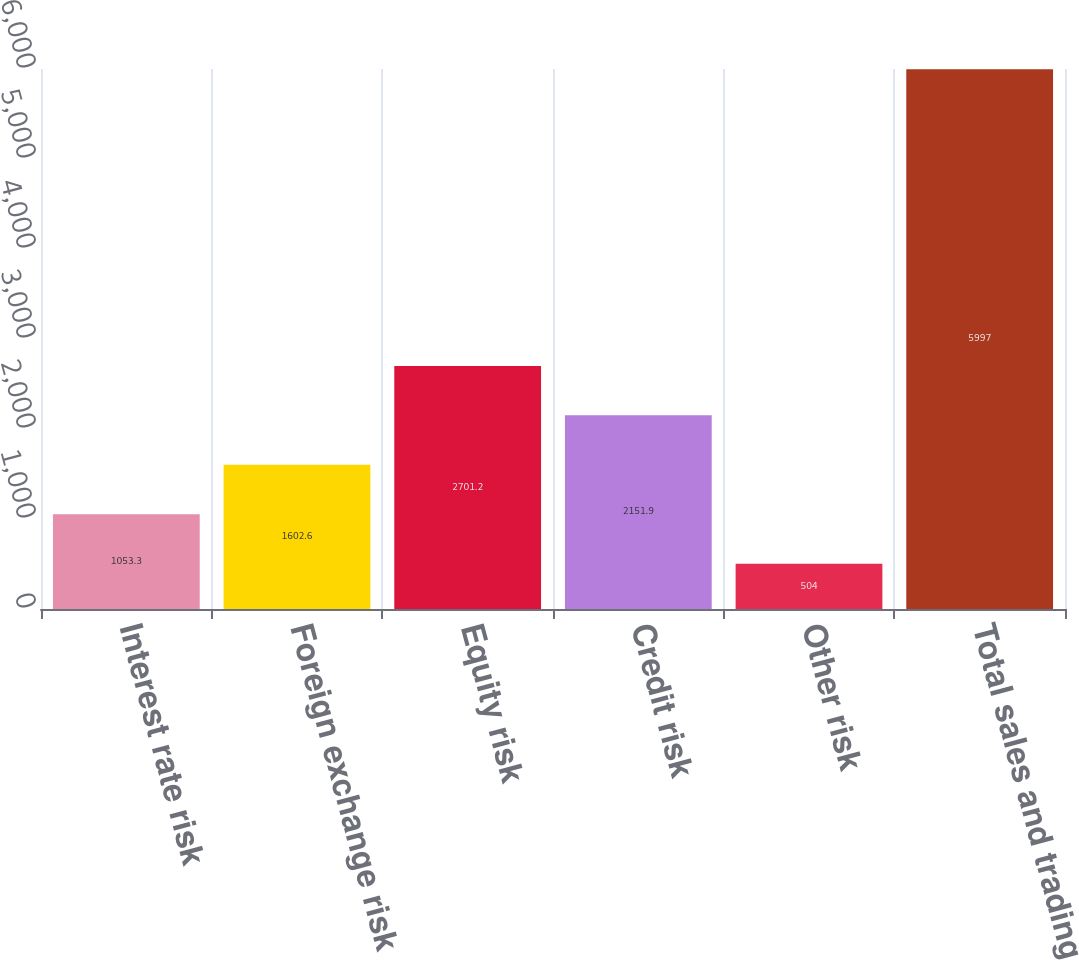Convert chart to OTSL. <chart><loc_0><loc_0><loc_500><loc_500><bar_chart><fcel>Interest rate risk<fcel>Foreign exchange risk<fcel>Equity risk<fcel>Credit risk<fcel>Other risk<fcel>Total sales and trading<nl><fcel>1053.3<fcel>1602.6<fcel>2701.2<fcel>2151.9<fcel>504<fcel>5997<nl></chart> 